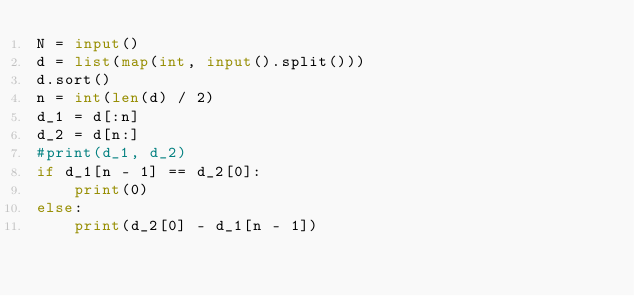Convert code to text. <code><loc_0><loc_0><loc_500><loc_500><_Python_>N = input()
d = list(map(int, input().split()))
d.sort()
n = int(len(d) / 2)
d_1 = d[:n]
d_2 = d[n:]
#print(d_1, d_2)
if d_1[n - 1] == d_2[0]:
    print(0)
else:
    print(d_2[0] - d_1[n - 1])</code> 